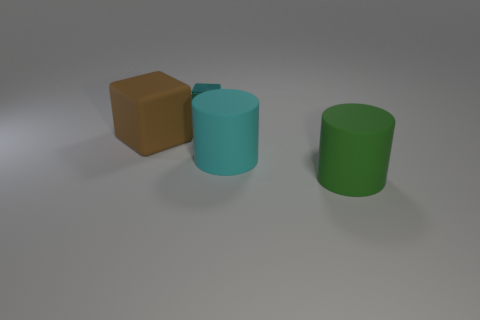Add 3 tiny cyan matte objects. How many objects exist? 7 Subtract all green cylinders. How many cylinders are left? 1 Subtract 0 purple cylinders. How many objects are left? 4 Subtract all gray cylinders. Subtract all green blocks. How many cylinders are left? 2 Subtract all tiny cyan shiny blocks. Subtract all cyan rubber things. How many objects are left? 2 Add 1 big cyan cylinders. How many big cyan cylinders are left? 2 Add 3 small blue cylinders. How many small blue cylinders exist? 3 